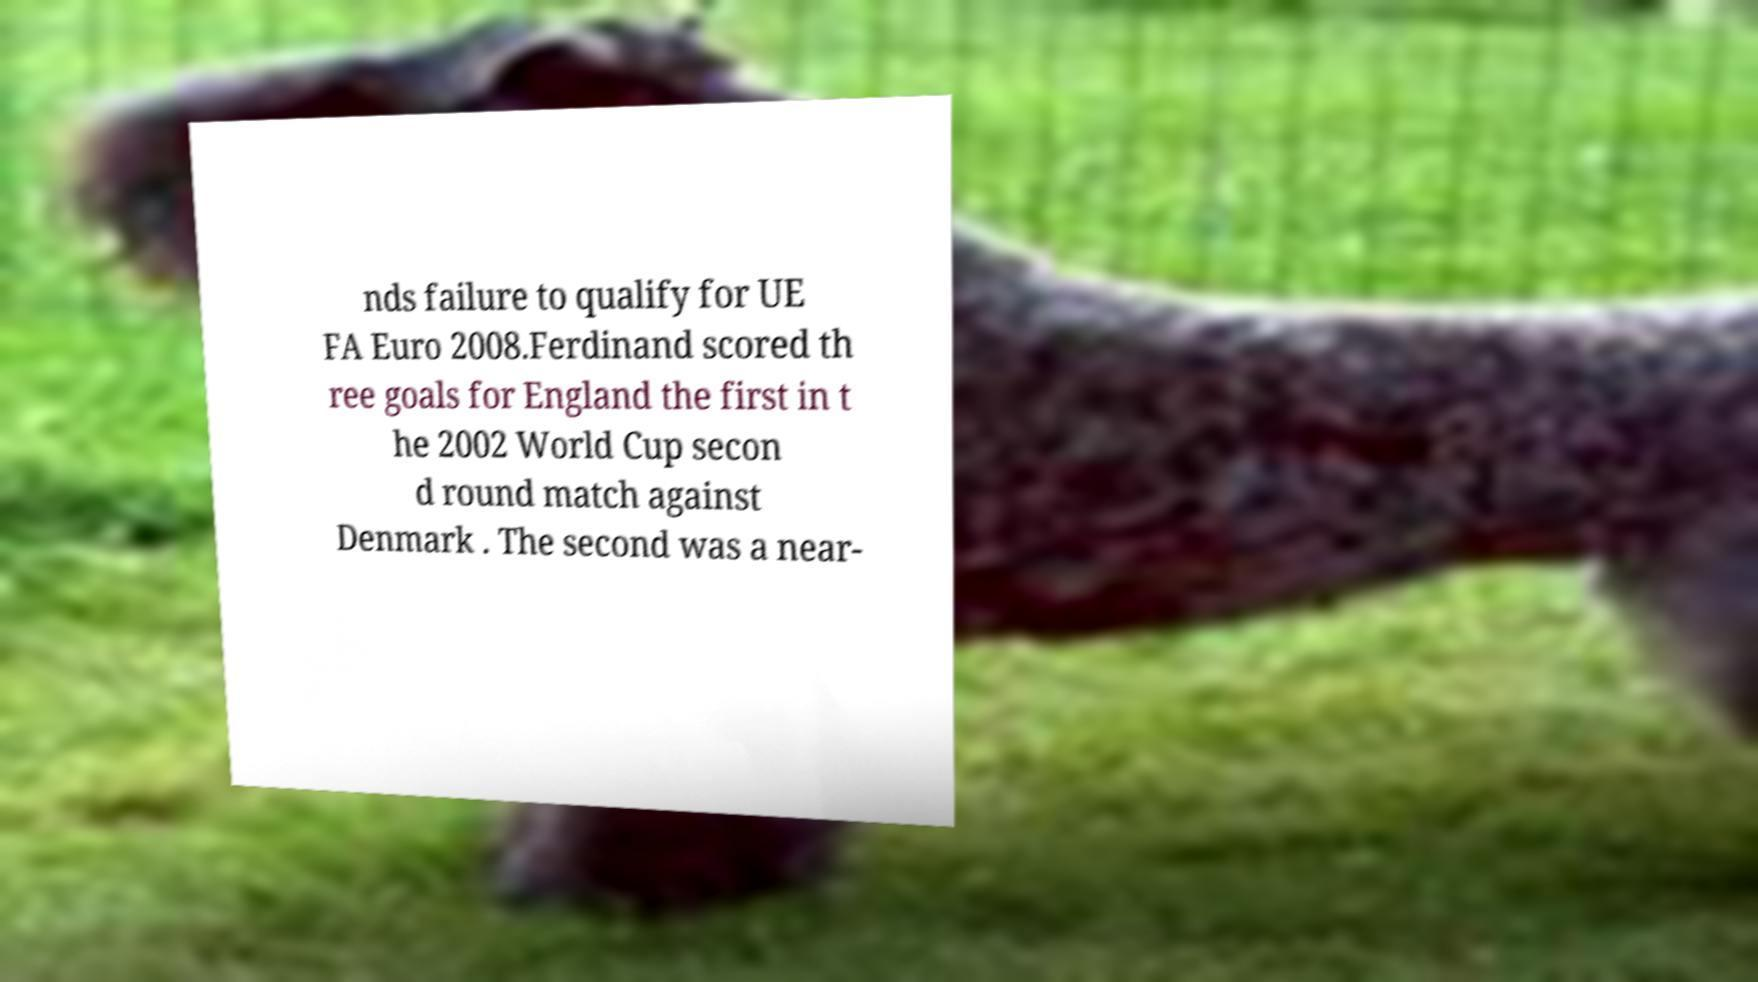Please identify and transcribe the text found in this image. nds failure to qualify for UE FA Euro 2008.Ferdinand scored th ree goals for England the first in t he 2002 World Cup secon d round match against Denmark . The second was a near- 